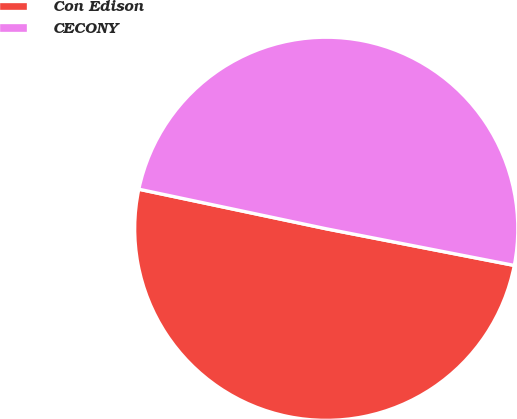Convert chart to OTSL. <chart><loc_0><loc_0><loc_500><loc_500><pie_chart><fcel>Con Edison<fcel>CECONY<nl><fcel>50.25%<fcel>49.75%<nl></chart> 